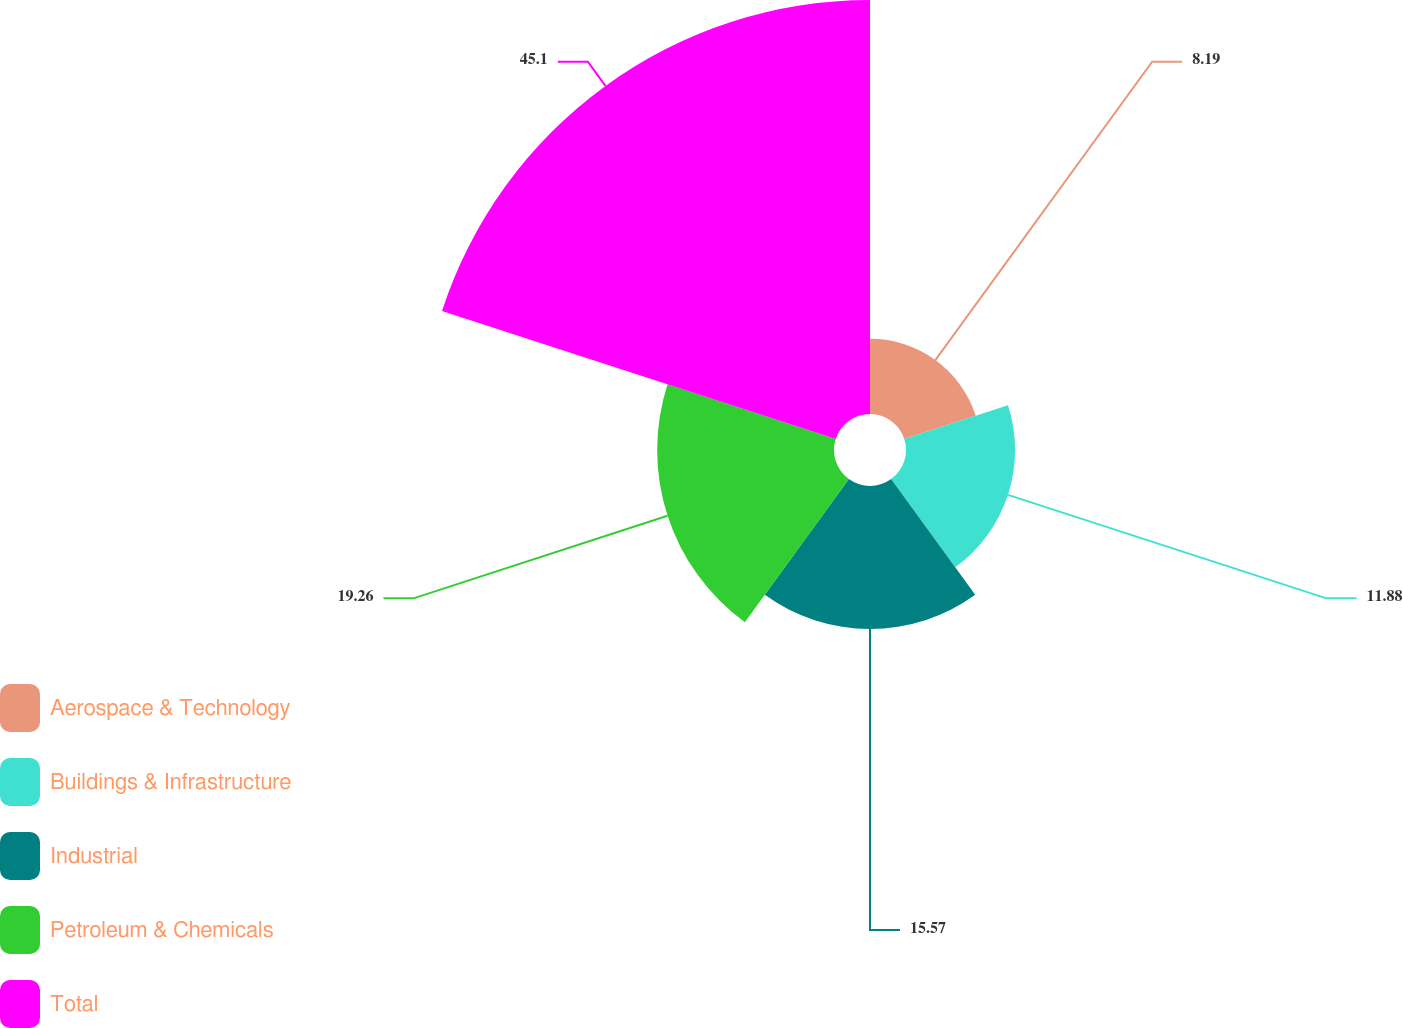<chart> <loc_0><loc_0><loc_500><loc_500><pie_chart><fcel>Aerospace & Technology<fcel>Buildings & Infrastructure<fcel>Industrial<fcel>Petroleum & Chemicals<fcel>Total<nl><fcel>8.19%<fcel>11.88%<fcel>15.57%<fcel>19.26%<fcel>45.09%<nl></chart> 